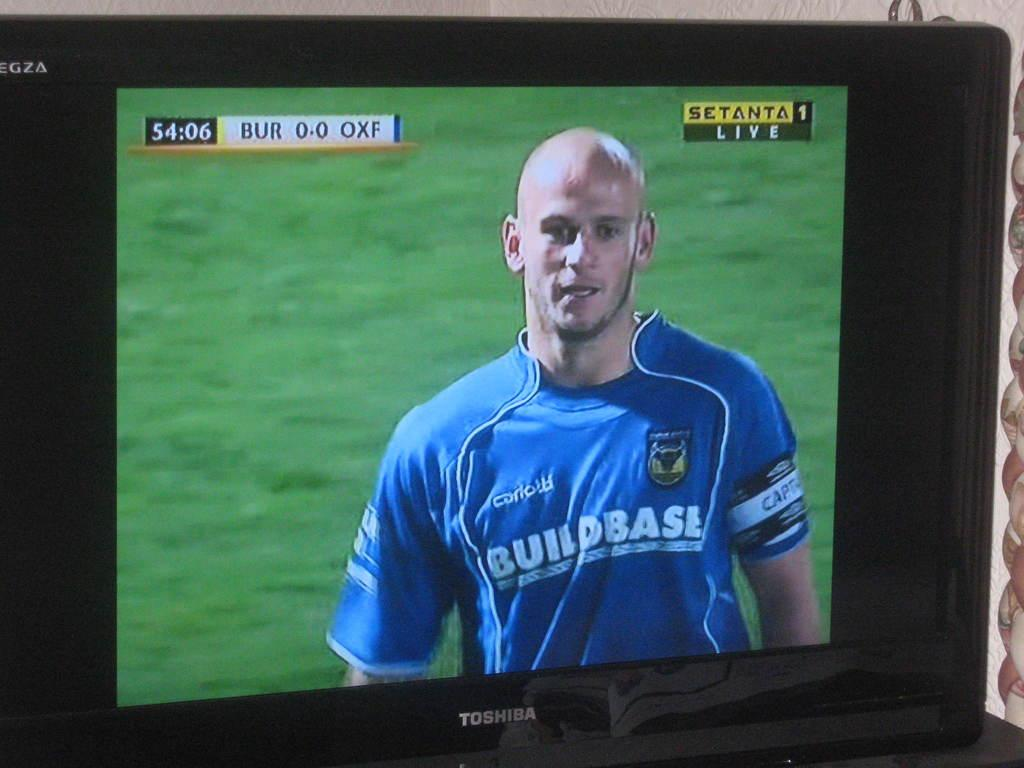Provide a one-sentence caption for the provided image. On a tv screen is a man wearing a blue shirt labeled BuildBase. 